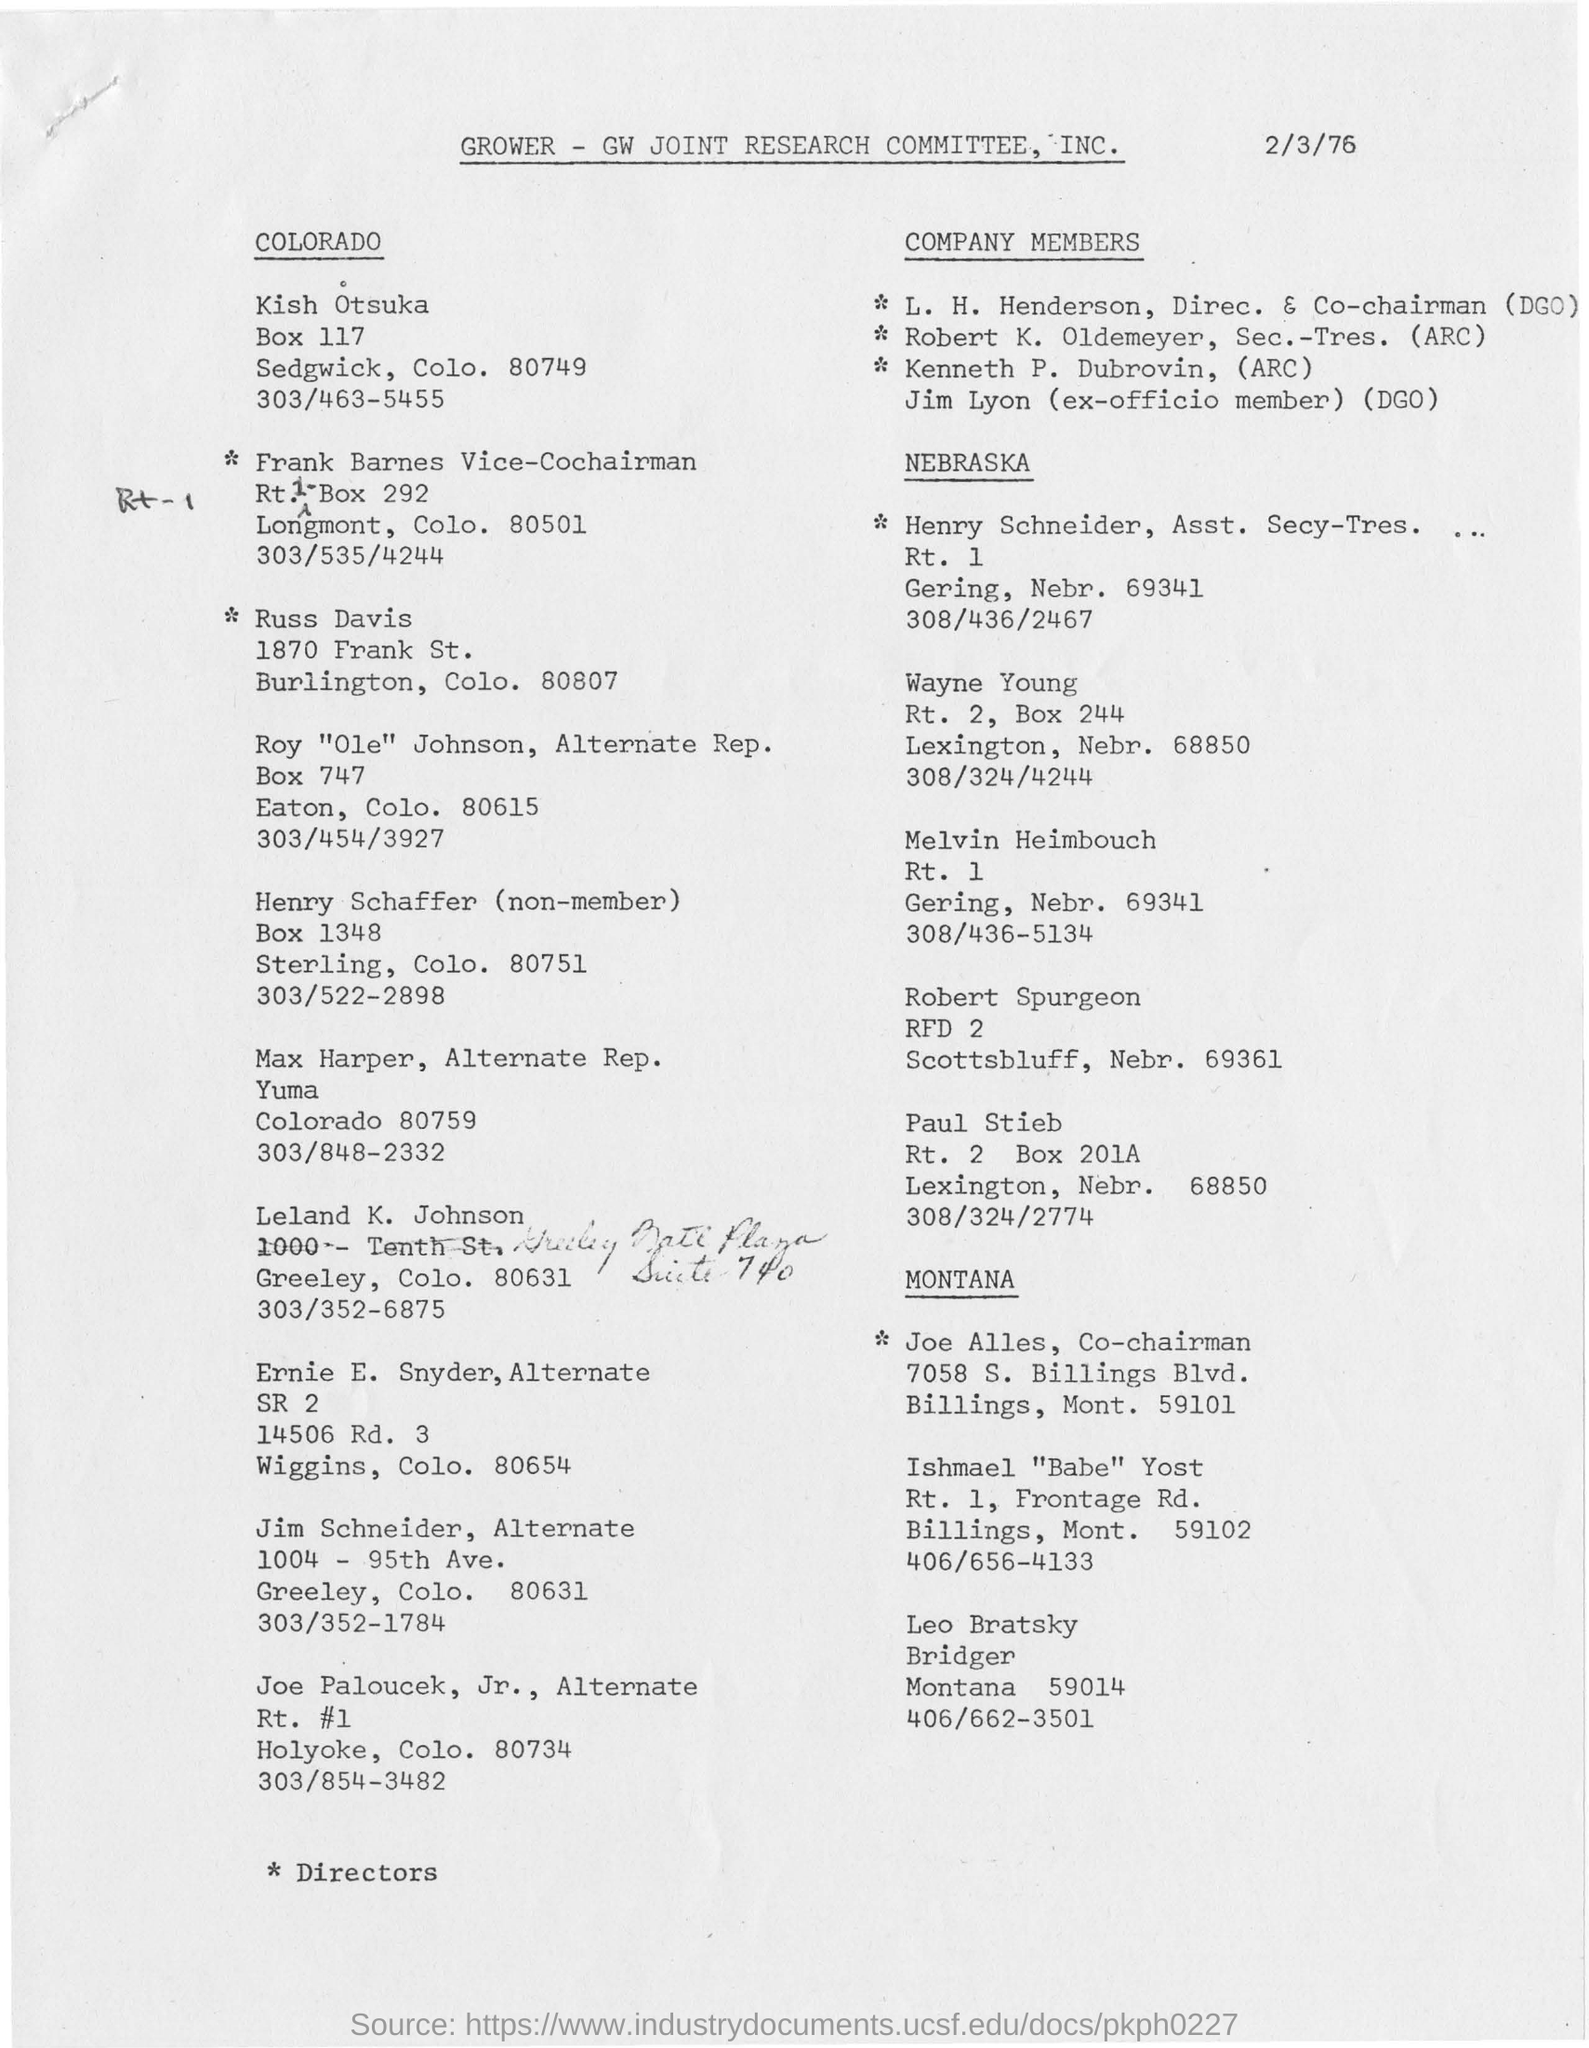Mention a couple of crucial points in this snapshot. The date mentioned in this document is February 3, 1976. The ex-officio member is Jim Lyon. L. H. Henderson's designation is Director and Co-Chairman (DGO). The document pertains to the GROWER-GW JOINT RESEARCH COMMITTEE, INC. 